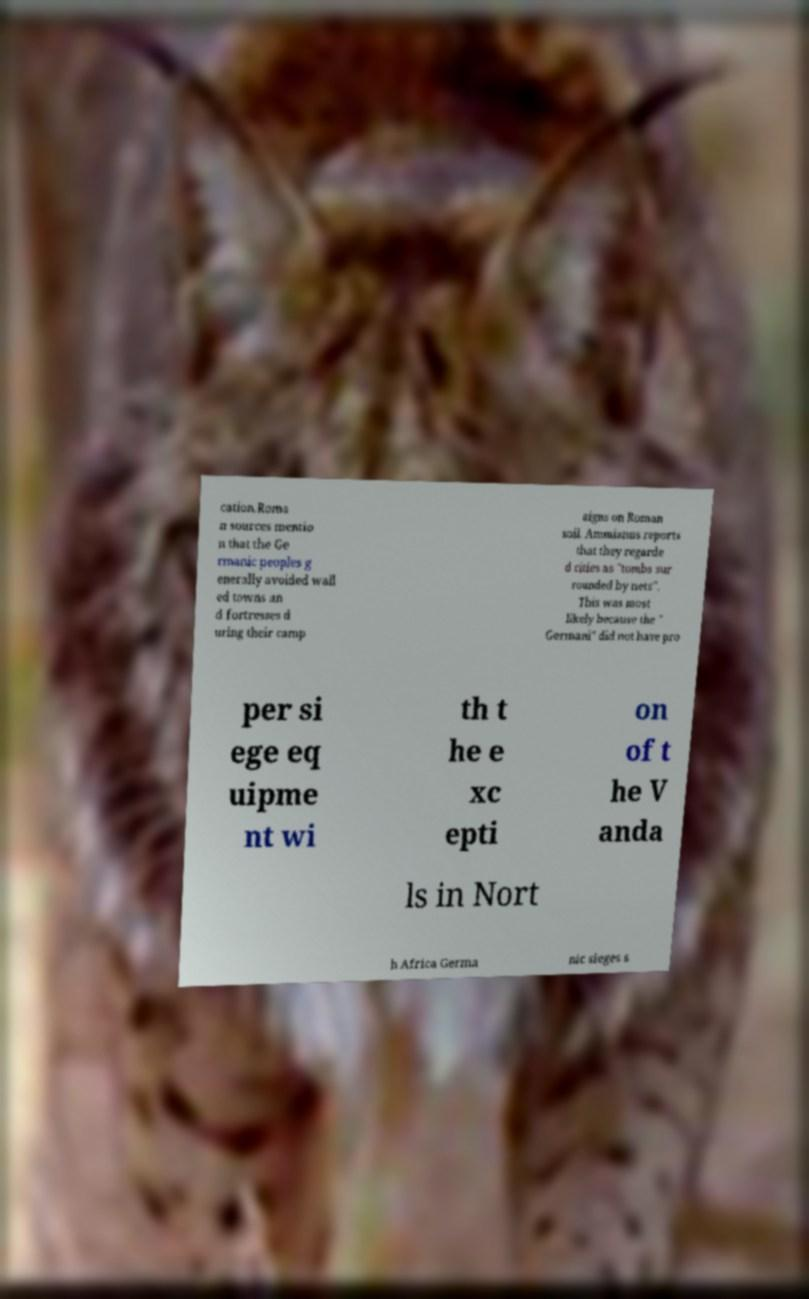I need the written content from this picture converted into text. Can you do that? cation.Roma n sources mentio n that the Ge rmanic peoples g enerally avoided wall ed towns an d fortresses d uring their camp aigns on Roman soil. Ammianus reports that they regarde d cities as "tombs sur rounded by nets". This was most likely because the " Germani" did not have pro per si ege eq uipme nt wi th t he e xc epti on of t he V anda ls in Nort h Africa Germa nic sieges s 